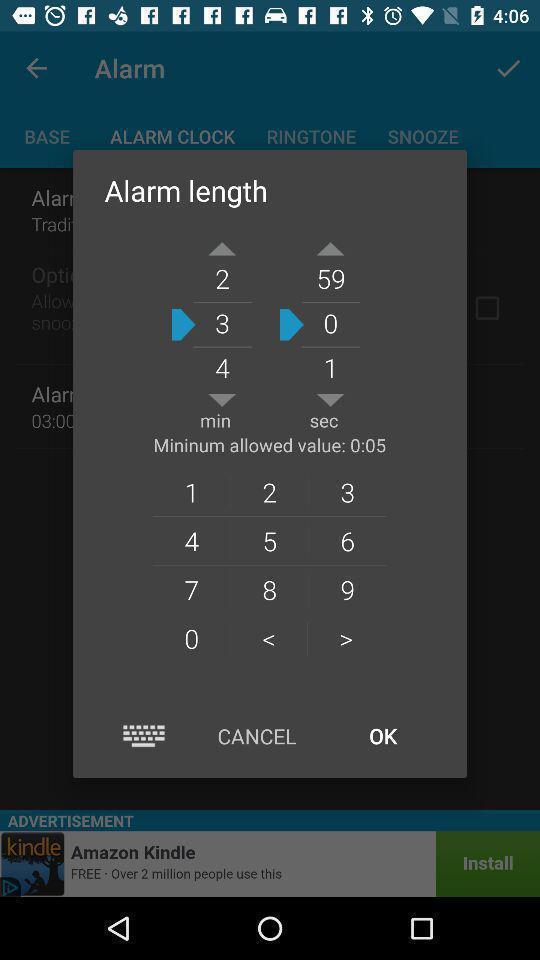Describe the content in this image. Pop-up window showing digits to set the alarm. 